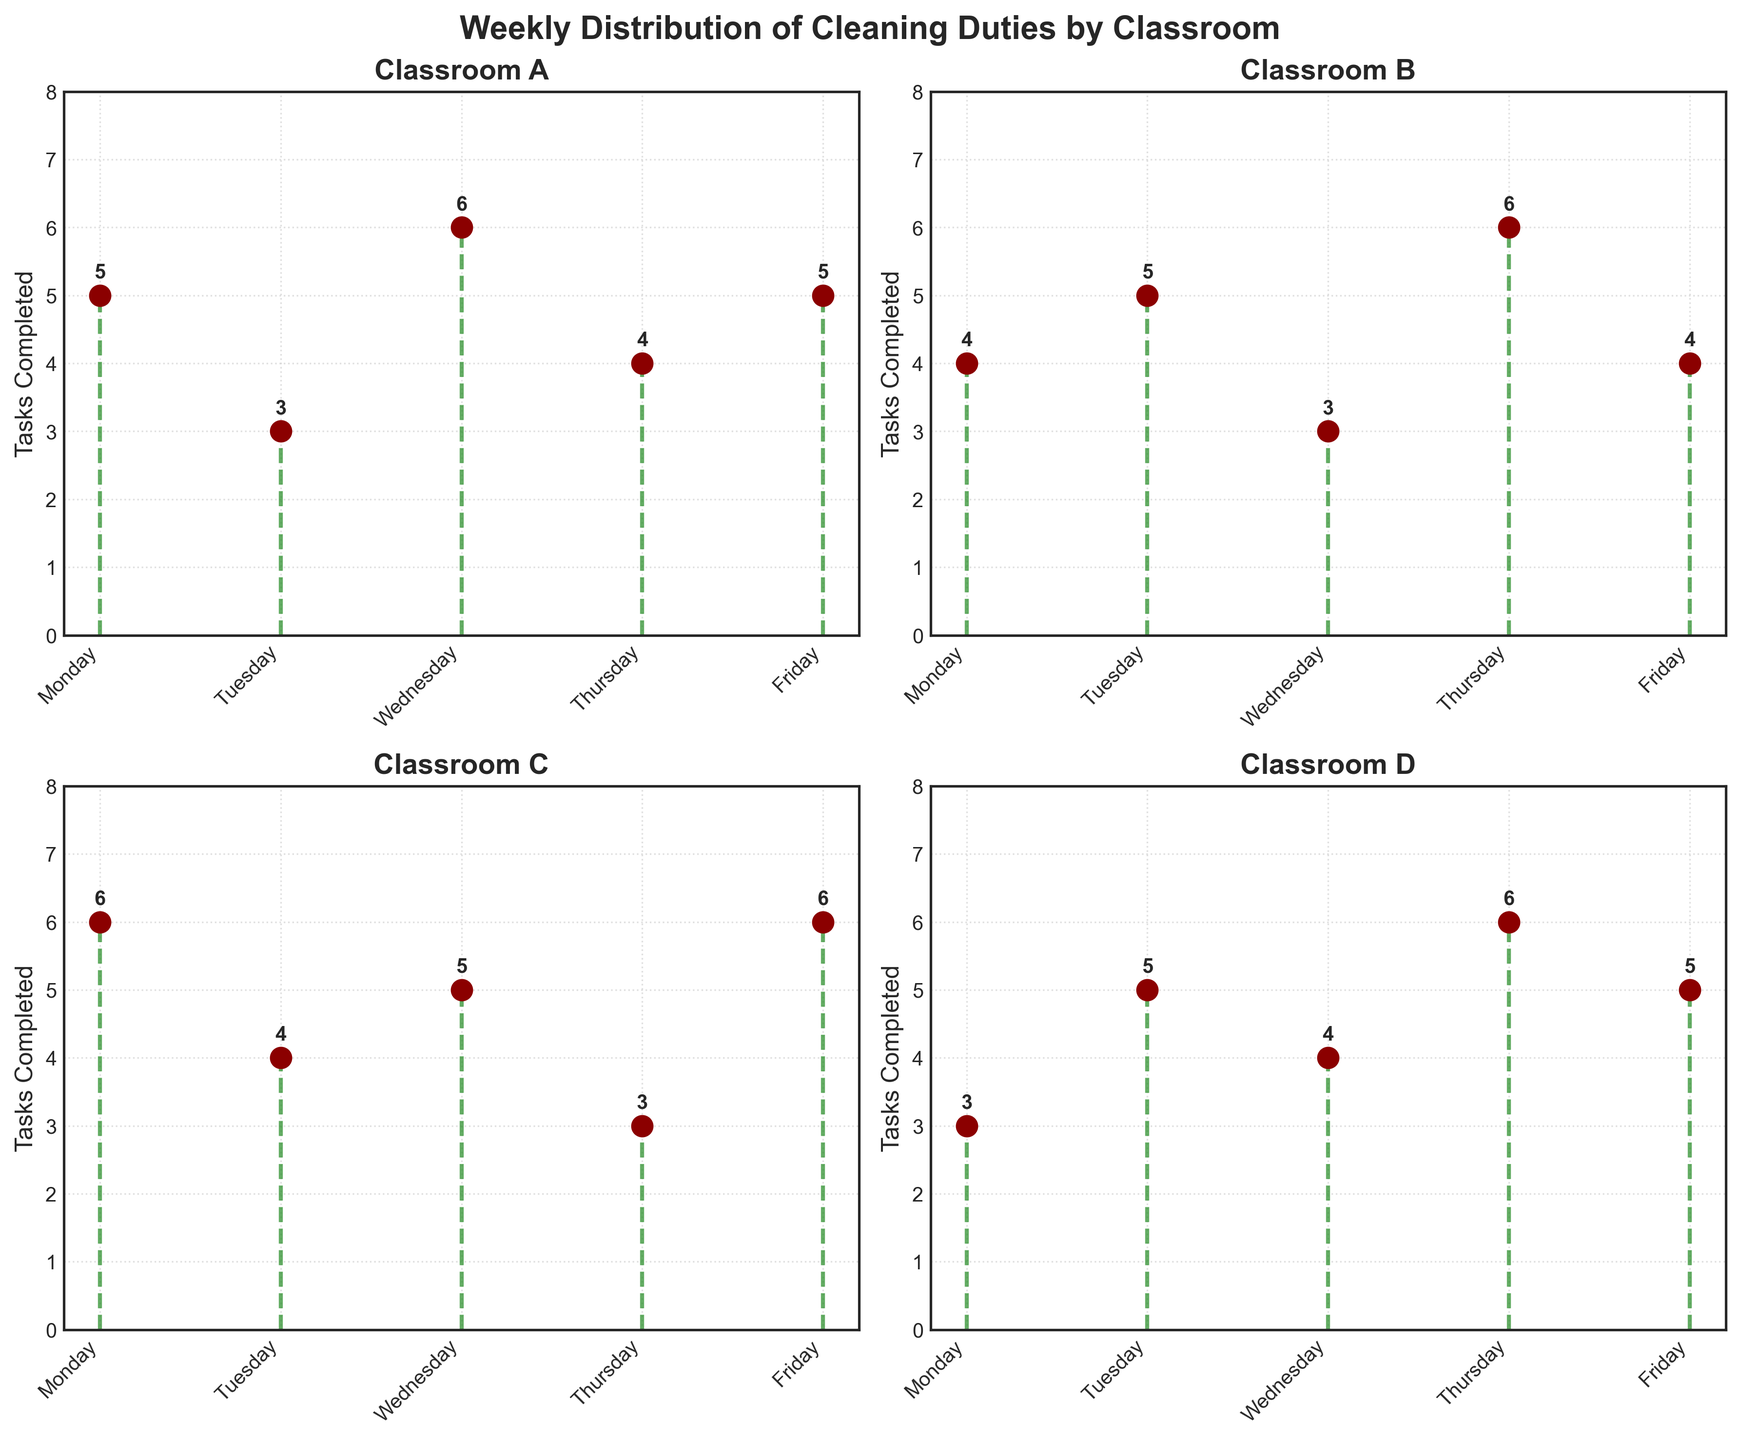How many tasks did Classroom A complete on Monday? The plot for Classroom A shows data for each day of the week. On Monday, the stem plot marker is at 5.
Answer: 5 Which classroom completed the most tasks on Wednesday? To find the classroom with the most tasks on Wednesday, look at Wednesday's values for each classroom. Classroom A: 6, Classroom B: 3, Classroom C: 5, Classroom D: 4. Classroom A has the highest value.
Answer: Classroom A What is the average number of tasks completed by Classroom B throughout the week? Add the total tasks for Classroom B (4+5+3+6+4 = 22) and divide by the number of days (5). The average is 22/5 = 4.4.
Answer: 4.4 How many more tasks did Classroom C complete on Friday compared to Thursday? For Classroom C, the tasks on Friday are 6, and on Thursday are 3. Subtract Thursday's value from Friday's (6-3).
Answer: 3 Which day had the most variability in tasks completed among all classrooms? Compare the range of tasks completed each day across all classrooms. Monday: 3-6, Tuesday: 3-5, Wednesday: 3-6, Thursday: 3-6, Friday: 4-6. Monday, Wednesday, and Thursday have the highest variability (3 tasks range).
Answer: Monday, Wednesday, Thursday On which days did Classroom D complete the same number of tasks? Look at Classroom D's tasks completed on each day to find repeated values. Tuesday and Friday both have 5 tasks completed.
Answer: Tuesday, Friday What is the total number of tasks completed by all classrooms on Thursday? Sum the tasks each classroom completed on Thursday. Classroom A: 4, Classroom B: 6, Classroom C: 3, Classroom D: 6. Sum equals 4+6+3+6 = 19.
Answer: 19 How does Classroom B’s task completion on Tuesday compare to Classroom C’s on the same day? Classroom B completed 5 tasks on Tuesday, and Classroom C completed 4 tasks. Classroom B completed 1 more task than Classroom C.
Answer: Classroom B completed 1 more task Which classroom had the most balanced distribution of tasks completed throughout the week? Find the classrooms with the smallest difference between their maximum and minimum tasks. Classroom A: 6-3 = 3, Classroom B: 6-3 = 3, Classroom C: 6-3 = 3, Classroom D: 6-3 = 3. All classrooms have the same range.
Answer: All classrooms What is the median number of tasks completed by Classroom A over the week? The tasks completed by Classroom A are 3, 4, 5, 5, 6. The median is the middle value when ordered (3, 4, 5, 5, 6).
Answer: 5 